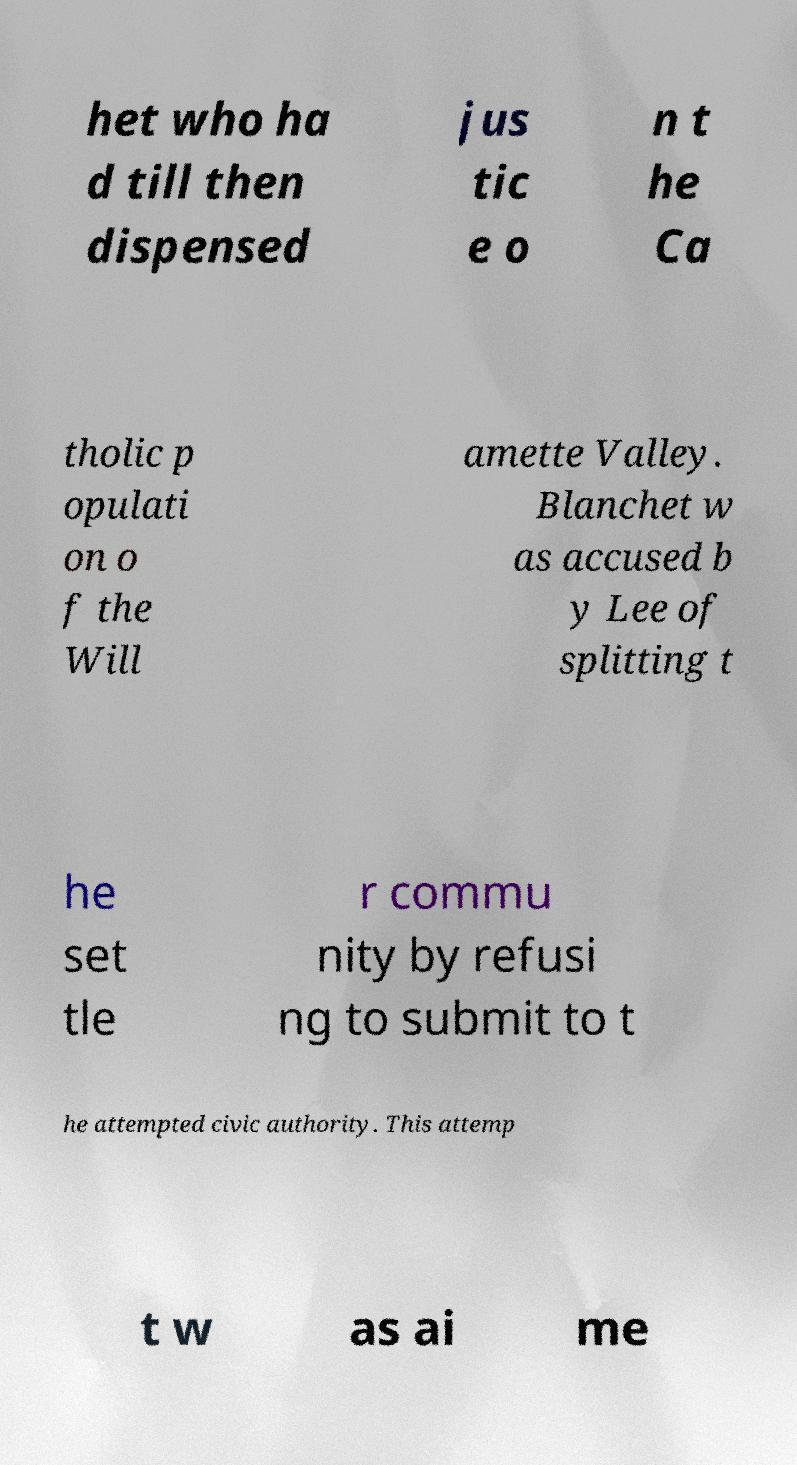Can you accurately transcribe the text from the provided image for me? het who ha d till then dispensed jus tic e o n t he Ca tholic p opulati on o f the Will amette Valley. Blanchet w as accused b y Lee of splitting t he set tle r commu nity by refusi ng to submit to t he attempted civic authority. This attemp t w as ai me 